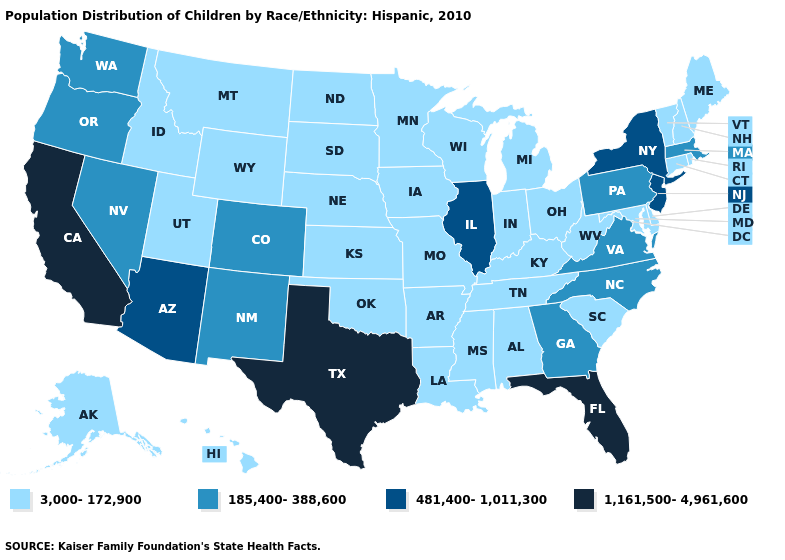What is the highest value in the USA?
Quick response, please. 1,161,500-4,961,600. Which states hav the highest value in the Northeast?
Give a very brief answer. New Jersey, New York. What is the highest value in the Northeast ?
Be succinct. 481,400-1,011,300. Among the states that border Vermont , does New Hampshire have the lowest value?
Give a very brief answer. Yes. What is the value of Michigan?
Concise answer only. 3,000-172,900. Which states hav the highest value in the South?
Short answer required. Florida, Texas. Does Massachusetts have a higher value than Texas?
Quick response, please. No. What is the value of Missouri?
Write a very short answer. 3,000-172,900. Does Rhode Island have the lowest value in the Northeast?
Give a very brief answer. Yes. Name the states that have a value in the range 185,400-388,600?
Short answer required. Colorado, Georgia, Massachusetts, Nevada, New Mexico, North Carolina, Oregon, Pennsylvania, Virginia, Washington. Is the legend a continuous bar?
Quick response, please. No. What is the lowest value in the USA?
Give a very brief answer. 3,000-172,900. Name the states that have a value in the range 481,400-1,011,300?
Be succinct. Arizona, Illinois, New Jersey, New York. What is the value of Iowa?
Be succinct. 3,000-172,900. Does the first symbol in the legend represent the smallest category?
Write a very short answer. Yes. 